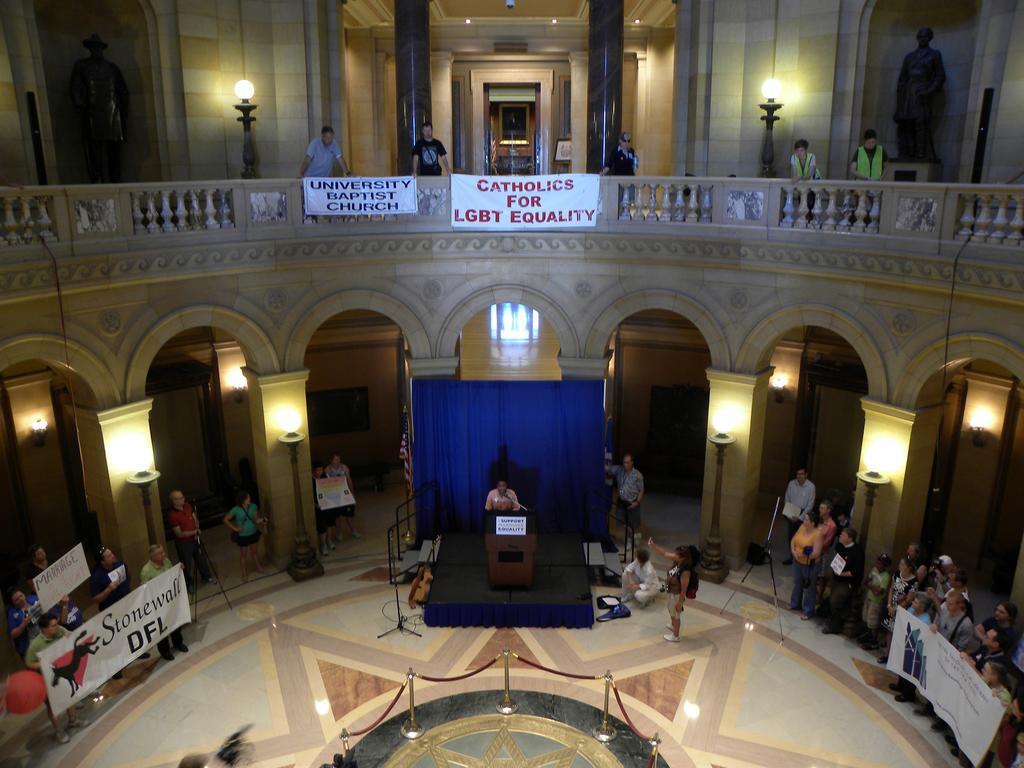How would you summarize this image in a sentence or two? In the center of the image we can see one stage. On the stage, we can see one person standing. In front of him, we can see one stand, one banner, one microphone and a few other objects. On the left side of the image we can see a few people are standing and they are holding banners. On the right side of the image we can see a few people are standing. Among them, we can see a few people are holding banners. In the background there is a wall, curtain, one door, poles, pillars, lights, statues, fences, banners, stands, one bag, few people are standing, few people are holding banners, one person is sitting and a few other objects. On the banners, we can see some text. 